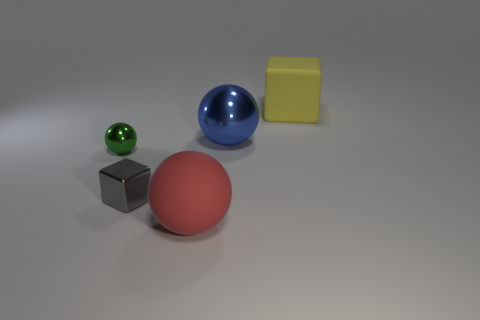Subtract all large red matte spheres. How many spheres are left? 2 Add 1 big brown objects. How many objects exist? 6 Subtract all gray blocks. How many blocks are left? 1 Subtract all spheres. How many objects are left? 2 Add 5 small cubes. How many small cubes are left? 6 Add 3 large metallic balls. How many large metallic balls exist? 4 Subtract 0 purple cylinders. How many objects are left? 5 Subtract 1 cubes. How many cubes are left? 1 Subtract all yellow blocks. Subtract all blue spheres. How many blocks are left? 1 Subtract all red blocks. How many red spheres are left? 1 